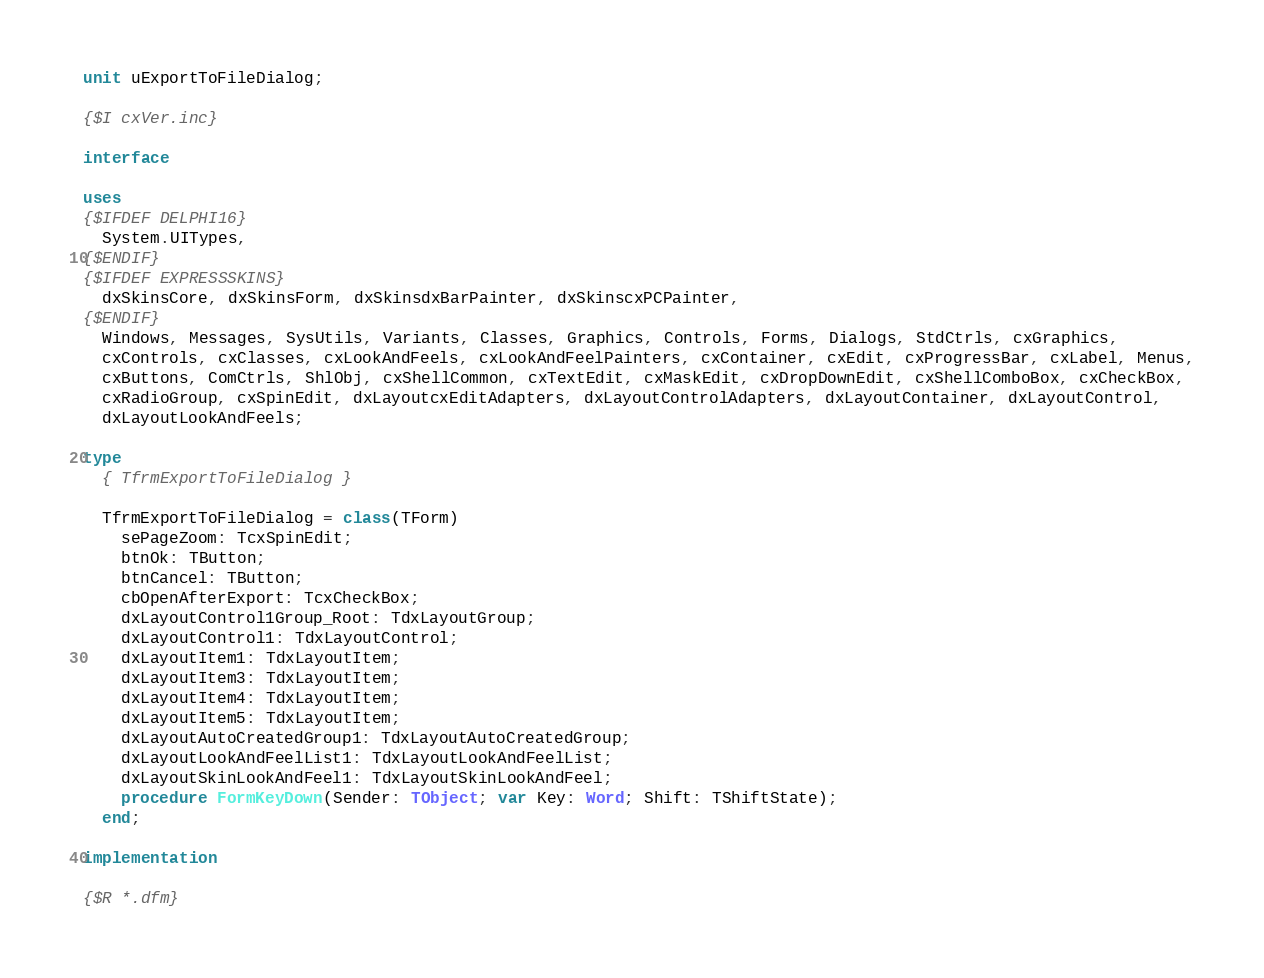Convert code to text. <code><loc_0><loc_0><loc_500><loc_500><_Pascal_>unit uExportToFileDialog;

{$I cxVer.inc}

interface

uses
{$IFDEF DELPHI16}
  System.UITypes,
{$ENDIF}
{$IFDEF EXPRESSSKINS}
  dxSkinsCore, dxSkinsForm, dxSkinsdxBarPainter, dxSkinscxPCPainter,
{$ENDIF}
  Windows, Messages, SysUtils, Variants, Classes, Graphics, Controls, Forms, Dialogs, StdCtrls, cxGraphics,
  cxControls, cxClasses, cxLookAndFeels, cxLookAndFeelPainters, cxContainer, cxEdit, cxProgressBar, cxLabel, Menus,
  cxButtons, ComCtrls, ShlObj, cxShellCommon, cxTextEdit, cxMaskEdit, cxDropDownEdit, cxShellComboBox, cxCheckBox,
  cxRadioGroup, cxSpinEdit, dxLayoutcxEditAdapters, dxLayoutControlAdapters, dxLayoutContainer, dxLayoutControl,
  dxLayoutLookAndFeels;

type
  { TfrmExportToFileDialog }

  TfrmExportToFileDialog = class(TForm)
    sePageZoom: TcxSpinEdit;
    btnOk: TButton;
    btnCancel: TButton;
    cbOpenAfterExport: TcxCheckBox;
    dxLayoutControl1Group_Root: TdxLayoutGroup;
    dxLayoutControl1: TdxLayoutControl;
    dxLayoutItem1: TdxLayoutItem;
    dxLayoutItem3: TdxLayoutItem;
    dxLayoutItem4: TdxLayoutItem;
    dxLayoutItem5: TdxLayoutItem;
    dxLayoutAutoCreatedGroup1: TdxLayoutAutoCreatedGroup;
    dxLayoutLookAndFeelList1: TdxLayoutLookAndFeelList;
    dxLayoutSkinLookAndFeel1: TdxLayoutSkinLookAndFeel;
    procedure FormKeyDown(Sender: TObject; var Key: Word; Shift: TShiftState);
  end;

implementation

{$R *.dfm}
</code> 